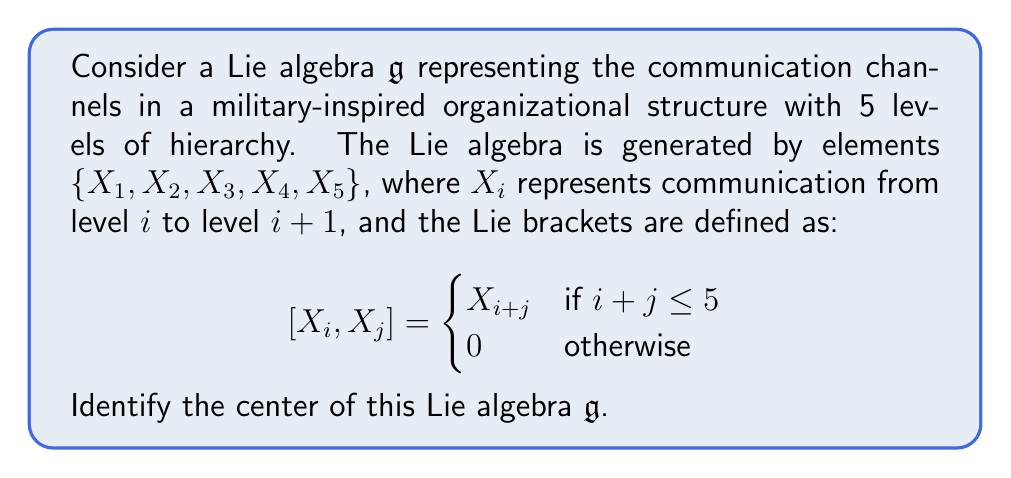Can you answer this question? To find the center of the Lie algebra $\mathfrak{g}$, we need to identify all elements $Z \in \mathfrak{g}$ that commute with every element in $\mathfrak{g}$. In other words, we need to find all $Z$ such that $[Z, X] = 0$ for all $X \in \mathfrak{g}$.

Let's consider a general element $Z = a_1X_1 + a_2X_2 + a_3X_3 + a_4X_4 + a_5X_5$ where $a_i \in \mathbb{R}$.

Step 1: Check $[Z, X_1]$
$$[Z, X_1] = a_1[X_1, X_1] + a_2[X_2, X_1] + a_3[X_3, X_1] + a_4[X_4, X_1] + a_5[X_5, X_1]$$
$$= 0 + a_2X_3 + a_3X_4 + a_4X_5 + 0$$

For $Z$ to be in the center, we need $a_2 = a_3 = a_4 = 0$.

Step 2: Check $[Z, X_2]$
$$[Z, X_2] = a_1[X_1, X_2] + a_2[X_2, X_2] + a_3[X_3, X_2] + a_4[X_4, X_2] + a_5[X_5, X_2]$$
$$= -a_1X_3 + 0 + a_3X_5 + 0 + 0$$

We already know $a_3 = 0$ from Step 1, so we need $a_1 = 0$ for $Z$ to be in the center.

Step 3: Check $[Z, X_3]$, $[Z, X_4]$, and $[Z, X_5]$
These all yield 0 due to the Lie bracket definition and the constraints we've already found.

Therefore, the only element that commutes with all generators is of the form $a_5X_5$, where $a_5 \in \mathbb{R}$.
Answer: The center of the Lie algebra $\mathfrak{g}$ is $Z(\mathfrak{g}) = \{aX_5 : a \in \mathbb{R}\}$, which is a one-dimensional subspace spanned by $X_5$. 